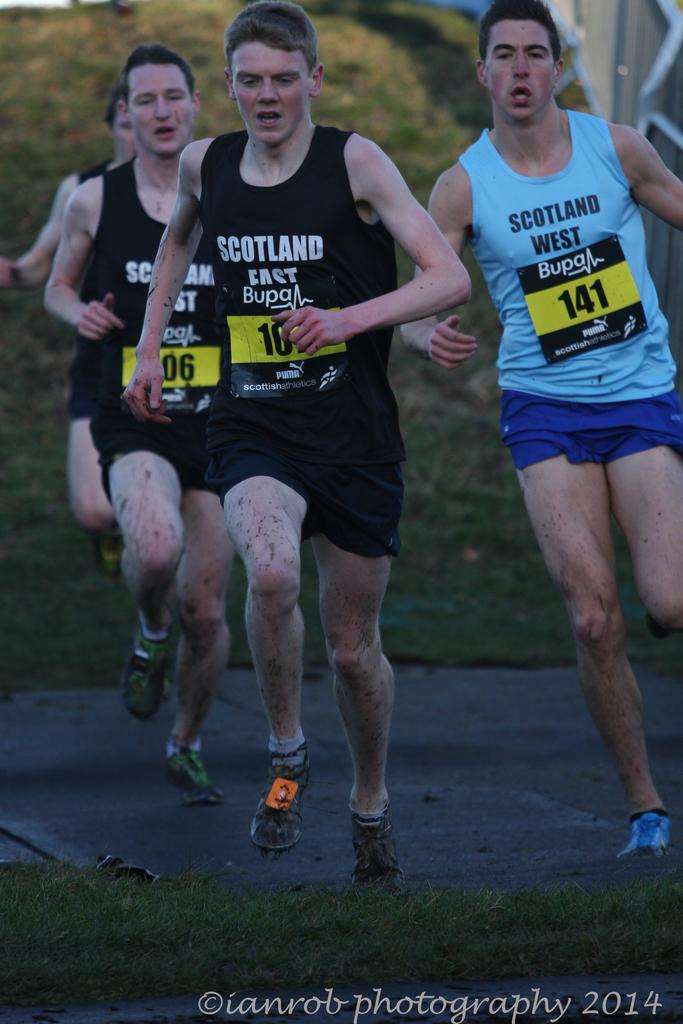What is happening in the image? There is a group of people in the image, and they are running. What type of surface can be seen in front of the group of people? There is a grass surface in front of the group of people. What type of cloth is being used by the people to sleep in the image? There is no cloth or sleeping activity depicted in the image; the people are running on a grass surface. 